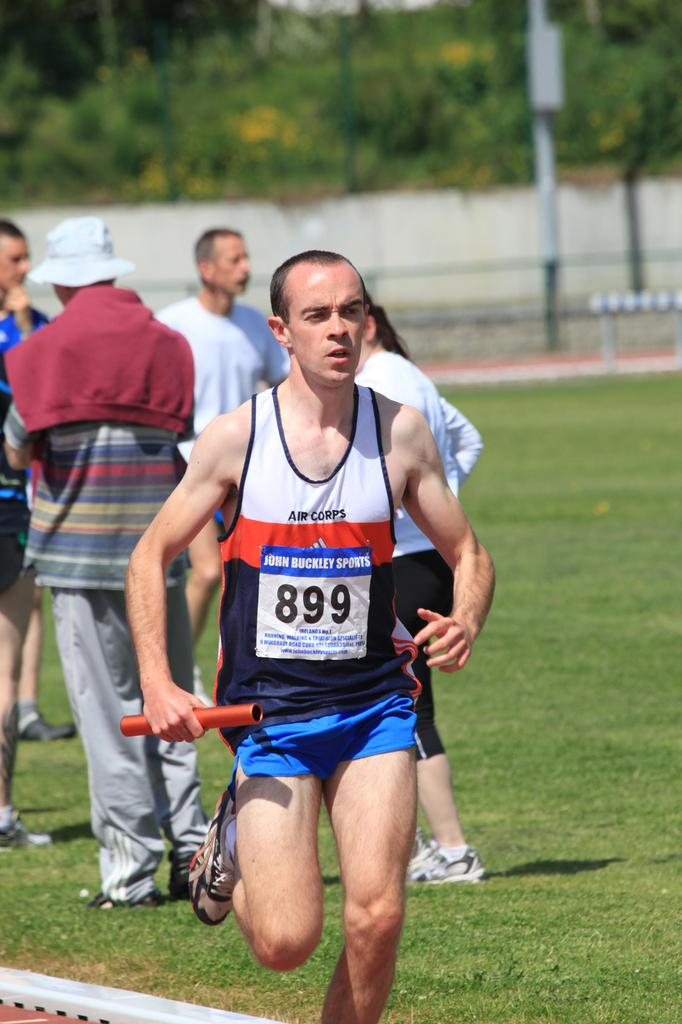<image>
Render a clear and concise summary of the photo. A man running a race is wearing the numbers 899. 